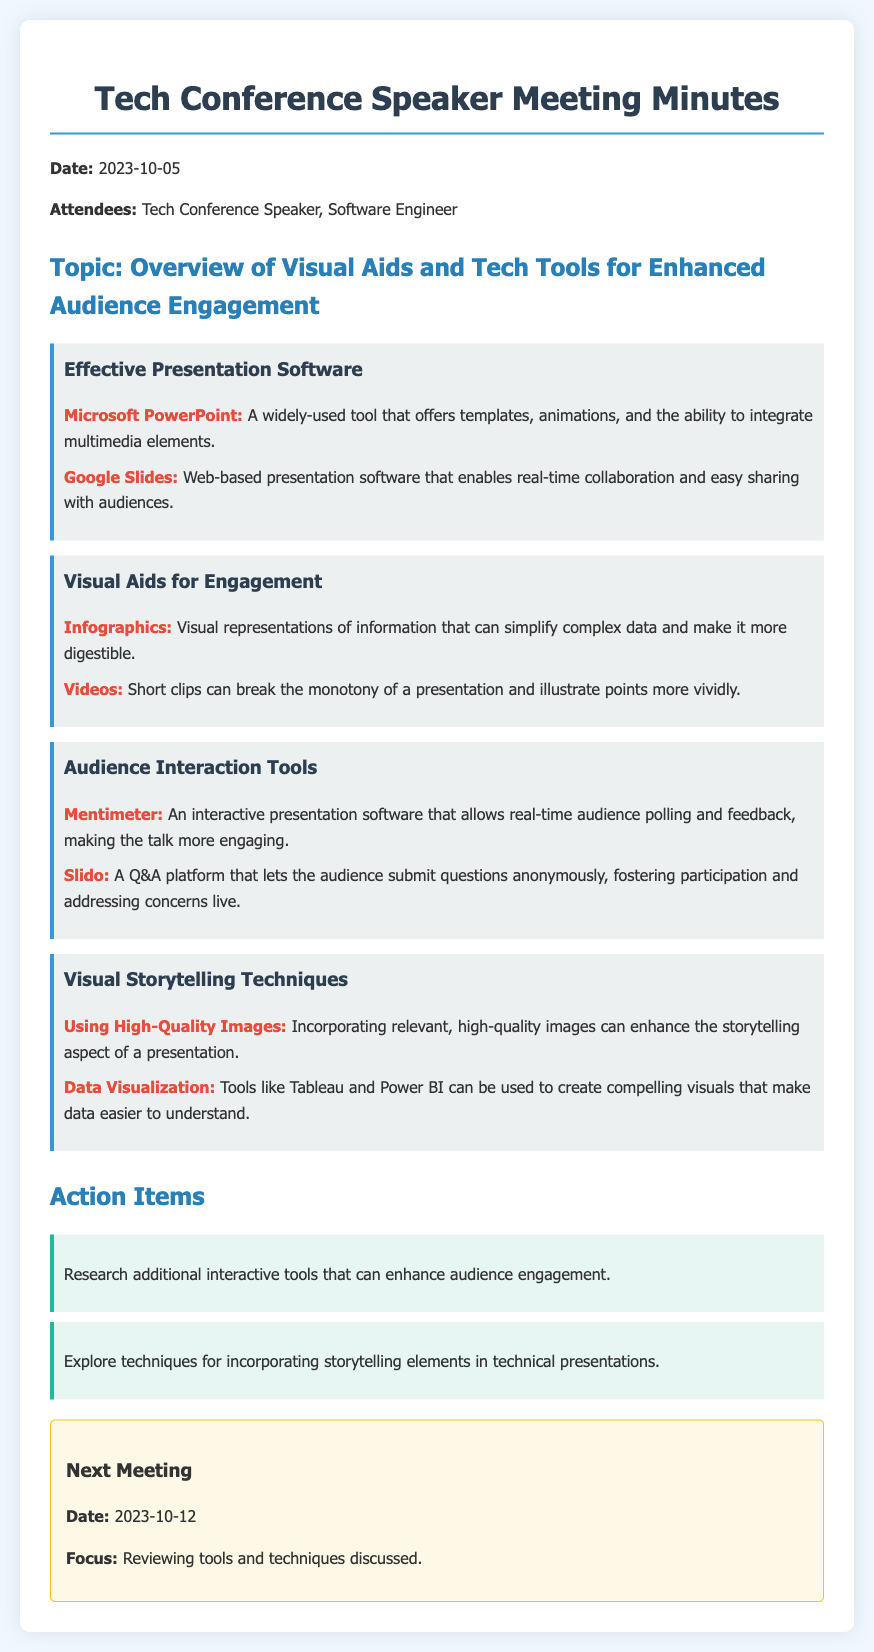What is the date of the meeting? The date of the meeting is stated at the beginning of the document.
Answer: 2023-10-05 Who are the attendees of the meeting? The attendees are listed in the document under the attendees section.
Answer: Tech Conference Speaker, Software Engineer What is one example of effective presentation software mentioned? The document provides specific examples of presentation software in the effective presentation software section.
Answer: Microsoft PowerPoint What are infographics classified as in the document? The document categorizes infographics under visual aids for engagement.
Answer: Visual aids Which tool allows for real-time audience polling? The audience interaction tools section specifies tools used for audience engagement, including one that facilitates polling.
Answer: Mentimeter What is the next meeting date? The date for the next meeting is specified towards the end of the document.
Answer: 2023-10-12 What technique involves using high-quality images? The document lists techniques for visual storytelling, including the use of images.
Answer: Using High-Quality Images What should be explored as an action item? The action items section lists what participants should research or evaluate further.
Answer: Techniques for incorporating storytelling elements in technical presentations 